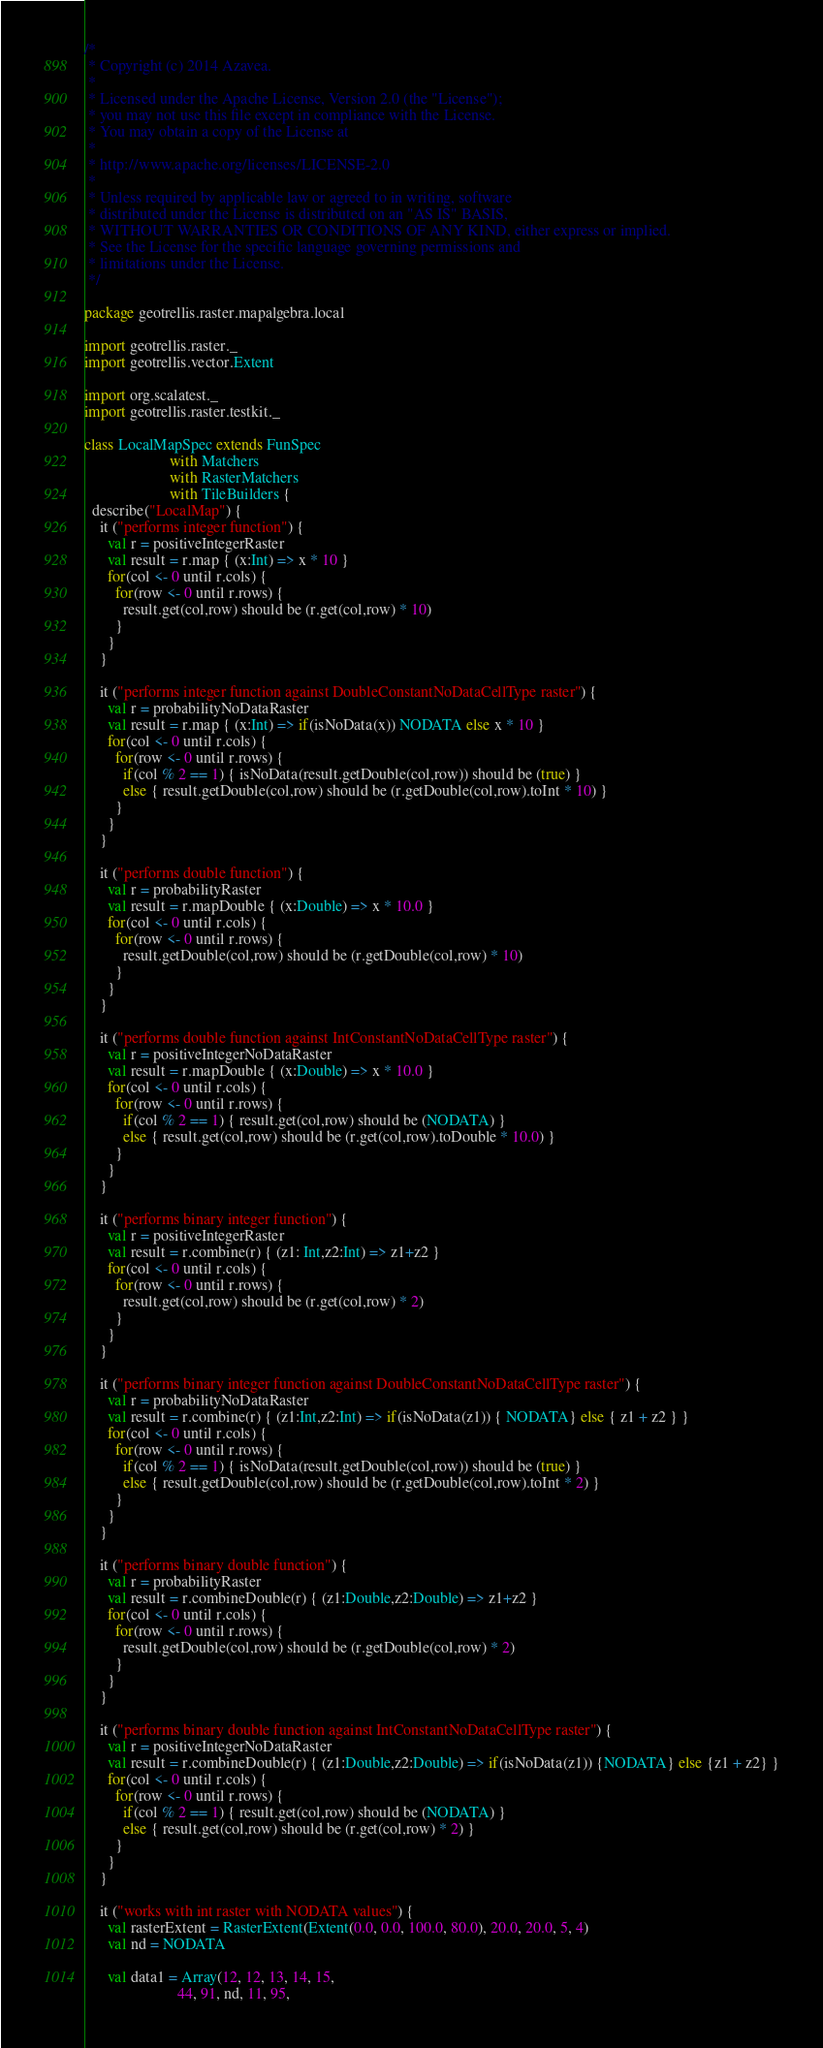<code> <loc_0><loc_0><loc_500><loc_500><_Scala_>/*
 * Copyright (c) 2014 Azavea.
 * 
 * Licensed under the Apache License, Version 2.0 (the "License");
 * you may not use this file except in compliance with the License.
 * You may obtain a copy of the License at
 * 
 * http://www.apache.org/licenses/LICENSE-2.0
 * 
 * Unless required by applicable law or agreed to in writing, software
 * distributed under the License is distributed on an "AS IS" BASIS,
 * WITHOUT WARRANTIES OR CONDITIONS OF ANY KIND, either express or implied.
 * See the License for the specific language governing permissions and
 * limitations under the License.
 */

package geotrellis.raster.mapalgebra.local

import geotrellis.raster._
import geotrellis.vector.Extent

import org.scalatest._
import geotrellis.raster.testkit._

class LocalMapSpec extends FunSpec 
                      with Matchers 
                      with RasterMatchers 
                      with TileBuilders {
  describe("LocalMap") {
    it ("performs integer function") {
      val r = positiveIntegerRaster
      val result = r.map { (x:Int) => x * 10 }
      for(col <- 0 until r.cols) {
        for(row <- 0 until r.rows) {
          result.get(col,row) should be (r.get(col,row) * 10)
        }
      }
    }

    it ("performs integer function against DoubleConstantNoDataCellType raster") {
      val r = probabilityNoDataRaster
      val result = r.map { (x:Int) => if(isNoData(x)) NODATA else x * 10 }
      for(col <- 0 until r.cols) {
        for(row <- 0 until r.rows) {
          if(col % 2 == 1) { isNoData(result.getDouble(col,row)) should be (true) }
          else { result.getDouble(col,row) should be (r.getDouble(col,row).toInt * 10) }
        }
      }
    }

    it ("performs double function") {
      val r = probabilityRaster
      val result = r.mapDouble { (x:Double) => x * 10.0 }
      for(col <- 0 until r.cols) {
        for(row <- 0 until r.rows) {
          result.getDouble(col,row) should be (r.getDouble(col,row) * 10)
        }
      }
    }

    it ("performs double function against IntConstantNoDataCellType raster") {
      val r = positiveIntegerNoDataRaster
      val result = r.mapDouble { (x:Double) => x * 10.0 }
      for(col <- 0 until r.cols) {
        for(row <- 0 until r.rows) {
          if(col % 2 == 1) { result.get(col,row) should be (NODATA) }
          else { result.get(col,row) should be (r.get(col,row).toDouble * 10.0) }
        }
      }
    }

    it ("performs binary integer function") {
      val r = positiveIntegerRaster
      val result = r.combine(r) { (z1: Int,z2:Int) => z1+z2 }
      for(col <- 0 until r.cols) {
        for(row <- 0 until r.rows) {
          result.get(col,row) should be (r.get(col,row) * 2)
        }
      }
    }

    it ("performs binary integer function against DoubleConstantNoDataCellType raster") {
      val r = probabilityNoDataRaster
      val result = r.combine(r) { (z1:Int,z2:Int) => if(isNoData(z1)) { NODATA} else { z1 + z2 } }
      for(col <- 0 until r.cols) {
        for(row <- 0 until r.rows) {
          if(col % 2 == 1) { isNoData(result.getDouble(col,row)) should be (true) }
          else { result.getDouble(col,row) should be (r.getDouble(col,row).toInt * 2) }
        }
      }
    }

    it ("performs binary double function") {
      val r = probabilityRaster
      val result = r.combineDouble(r) { (z1:Double,z2:Double) => z1+z2 }
      for(col <- 0 until r.cols) {
        for(row <- 0 until r.rows) {
          result.getDouble(col,row) should be (r.getDouble(col,row) * 2)
        }
      }
    }

    it ("performs binary double function against IntConstantNoDataCellType raster") {
      val r = positiveIntegerNoDataRaster
      val result = r.combineDouble(r) { (z1:Double,z2:Double) => if(isNoData(z1)) {NODATA} else {z1 + z2} }
      for(col <- 0 until r.cols) {
        for(row <- 0 until r.rows) {
          if(col % 2 == 1) { result.get(col,row) should be (NODATA) }
          else { result.get(col,row) should be (r.get(col,row) * 2) }
        }
      }
    }

    it ("works with int raster with NODATA values") {
      val rasterExtent = RasterExtent(Extent(0.0, 0.0, 100.0, 80.0), 20.0, 20.0, 5, 4)
      val nd = NODATA
      
      val data1 = Array(12, 12, 13, 14, 15,
                        44, 91, nd, 11, 95,</code> 